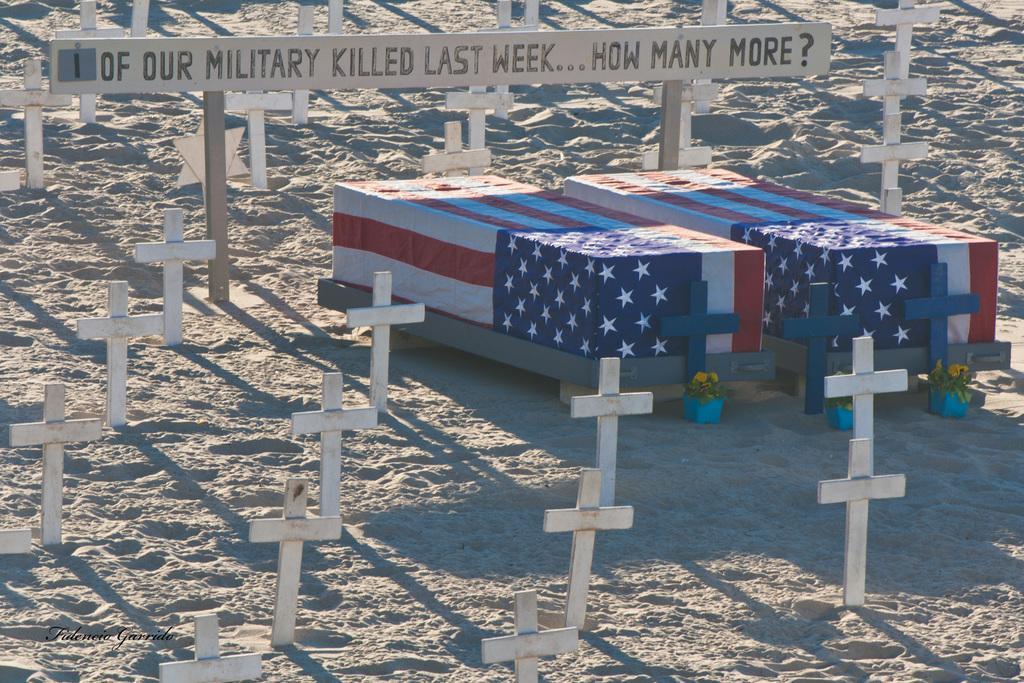Describe this image in one or two sentences. In this image there are two coffin boxes covered with flags around the coffins there are cross on the surface and there is some text written on a wooden stick, at the bottom of the image there is some text written, in front of the coffins there are flowers. 